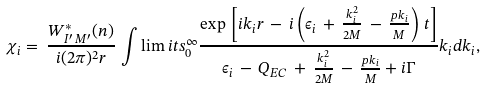Convert formula to latex. <formula><loc_0><loc_0><loc_500><loc_500>\chi _ { i } = \, \frac { W ^ { * } _ { I ^ { \prime } \, M ^ { \prime } } ( n ) } { i ( 2 \pi ) ^ { 2 } r } \, \int \lim i t s ^ { \infty } _ { 0 } \frac { \exp { \, \left [ i k _ { i } r \, - \, i \left ( \epsilon _ { i } \, + \, \frac { k ^ { 2 } _ { i } } { 2 M } \, - \, \frac { p k _ { i } } { M } \right ) \, t \right ] } } { \epsilon _ { i } \, - \, Q _ { E C } \, + \, \frac { k ^ { 2 } _ { i } } { 2 M } \, - \, \frac { p k _ { i } } { M } + i \Gamma } k _ { i } d k _ { i } ,</formula> 